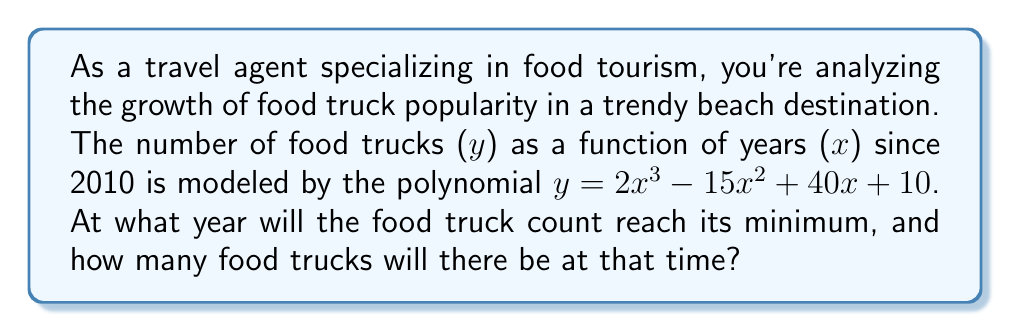Teach me how to tackle this problem. To solve this problem, we need to follow these steps:

1) The minimum point of a polynomial function occurs where its derivative equals zero. Let's find the derivative of $y = 2x^3 - 15x^2 + 40x + 10$.

   $y' = 6x^2 - 30x + 40$

2) Set the derivative equal to zero and solve for x:

   $6x^2 - 30x + 40 = 0$

3) This is a quadratic equation. We can solve it using the quadratic formula:
   $x = \frac{-b \pm \sqrt{b^2 - 4ac}}{2a}$

   Where $a = 6$, $b = -30$, and $c = 40$

4) Plugging these values into the quadratic formula:

   $x = \frac{30 \pm \sqrt{(-30)^2 - 4(6)(40)}}{2(6)}$

   $= \frac{30 \pm \sqrt{900 - 960}}{12}$

   $= \frac{30 \pm \sqrt{-60}}{12}$

   $= \frac{30 \pm i\sqrt{60}}{12}$

5) Since we're dealing with real years, we only consider the real part:

   $x = \frac{30}{12} = 2.5$

6) This means the minimum occurs 2.5 years after 2010, which is mid-2012.

7) To find the number of food trucks at this time, we plug x = 2.5 into the original equation:

   $y = 2(2.5)^3 - 15(2.5)^2 + 40(2.5) + 10$
   $= 2(15.625) - 15(6.25) + 100 + 10$
   $= 31.25 - 93.75 + 110$
   $= 47.5$

Therefore, the minimum number of food trucks will be 47.5 (or 48, rounding up to the nearest whole truck) in mid-2012.
Answer: Mid-2012; 48 food trucks 